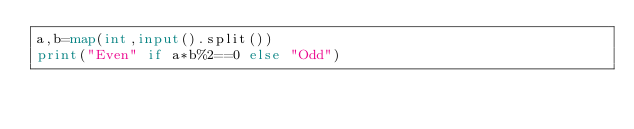Convert code to text. <code><loc_0><loc_0><loc_500><loc_500><_Python_>a,b=map(int,input().split())
print("Even" if a*b%2==0 else "Odd")</code> 